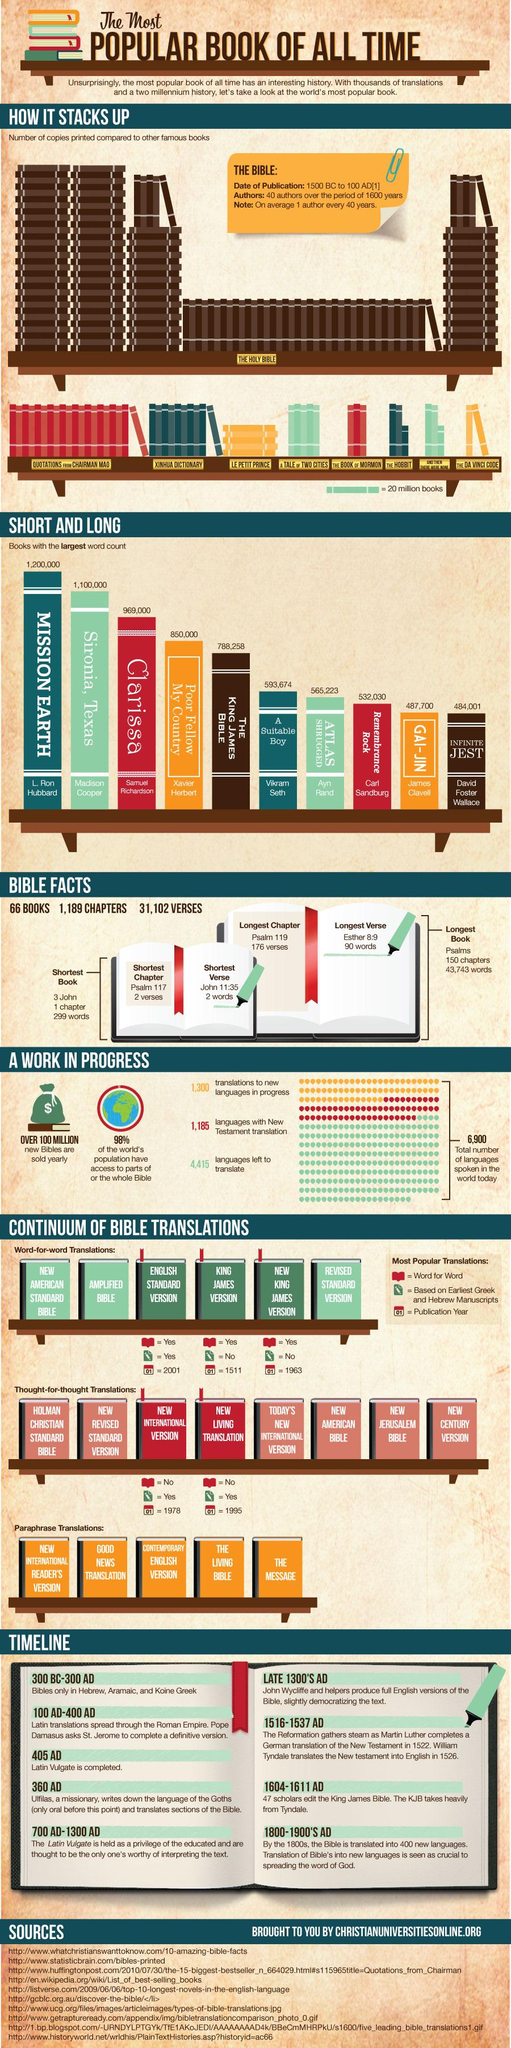Outline some significant characteristics in this image. Samuel Richardson is the author of "Clarissa. Psalm 117 is the shortest chapter of the Bible. Psalms is the longest book of the Bible. The Bible was written by 40 people. Psalm 119 is the longest chapter in the Bible. 